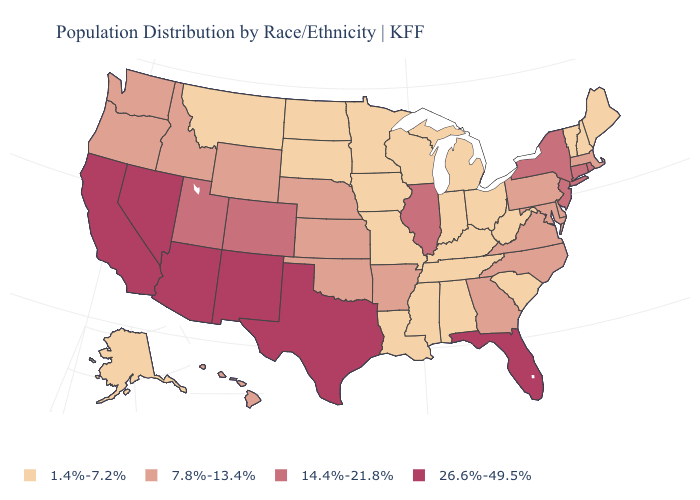Does the first symbol in the legend represent the smallest category?
Write a very short answer. Yes. What is the value of Connecticut?
Give a very brief answer. 14.4%-21.8%. Among the states that border Florida , does Georgia have the highest value?
Short answer required. Yes. What is the value of Rhode Island?
Write a very short answer. 14.4%-21.8%. What is the highest value in the USA?
Keep it brief. 26.6%-49.5%. Which states have the highest value in the USA?
Give a very brief answer. Arizona, California, Florida, Nevada, New Mexico, Texas. Name the states that have a value in the range 1.4%-7.2%?
Short answer required. Alabama, Alaska, Indiana, Iowa, Kentucky, Louisiana, Maine, Michigan, Minnesota, Mississippi, Missouri, Montana, New Hampshire, North Dakota, Ohio, South Carolina, South Dakota, Tennessee, Vermont, West Virginia, Wisconsin. Name the states that have a value in the range 14.4%-21.8%?
Answer briefly. Colorado, Connecticut, Illinois, New Jersey, New York, Rhode Island, Utah. What is the highest value in the USA?
Keep it brief. 26.6%-49.5%. What is the value of Michigan?
Quick response, please. 1.4%-7.2%. Name the states that have a value in the range 1.4%-7.2%?
Be succinct. Alabama, Alaska, Indiana, Iowa, Kentucky, Louisiana, Maine, Michigan, Minnesota, Mississippi, Missouri, Montana, New Hampshire, North Dakota, Ohio, South Carolina, South Dakota, Tennessee, Vermont, West Virginia, Wisconsin. Does Delaware have a lower value than Massachusetts?
Keep it brief. No. Name the states that have a value in the range 7.8%-13.4%?
Give a very brief answer. Arkansas, Delaware, Georgia, Hawaii, Idaho, Kansas, Maryland, Massachusetts, Nebraska, North Carolina, Oklahoma, Oregon, Pennsylvania, Virginia, Washington, Wyoming. Name the states that have a value in the range 26.6%-49.5%?
Write a very short answer. Arizona, California, Florida, Nevada, New Mexico, Texas. What is the lowest value in states that border Michigan?
Quick response, please. 1.4%-7.2%. 